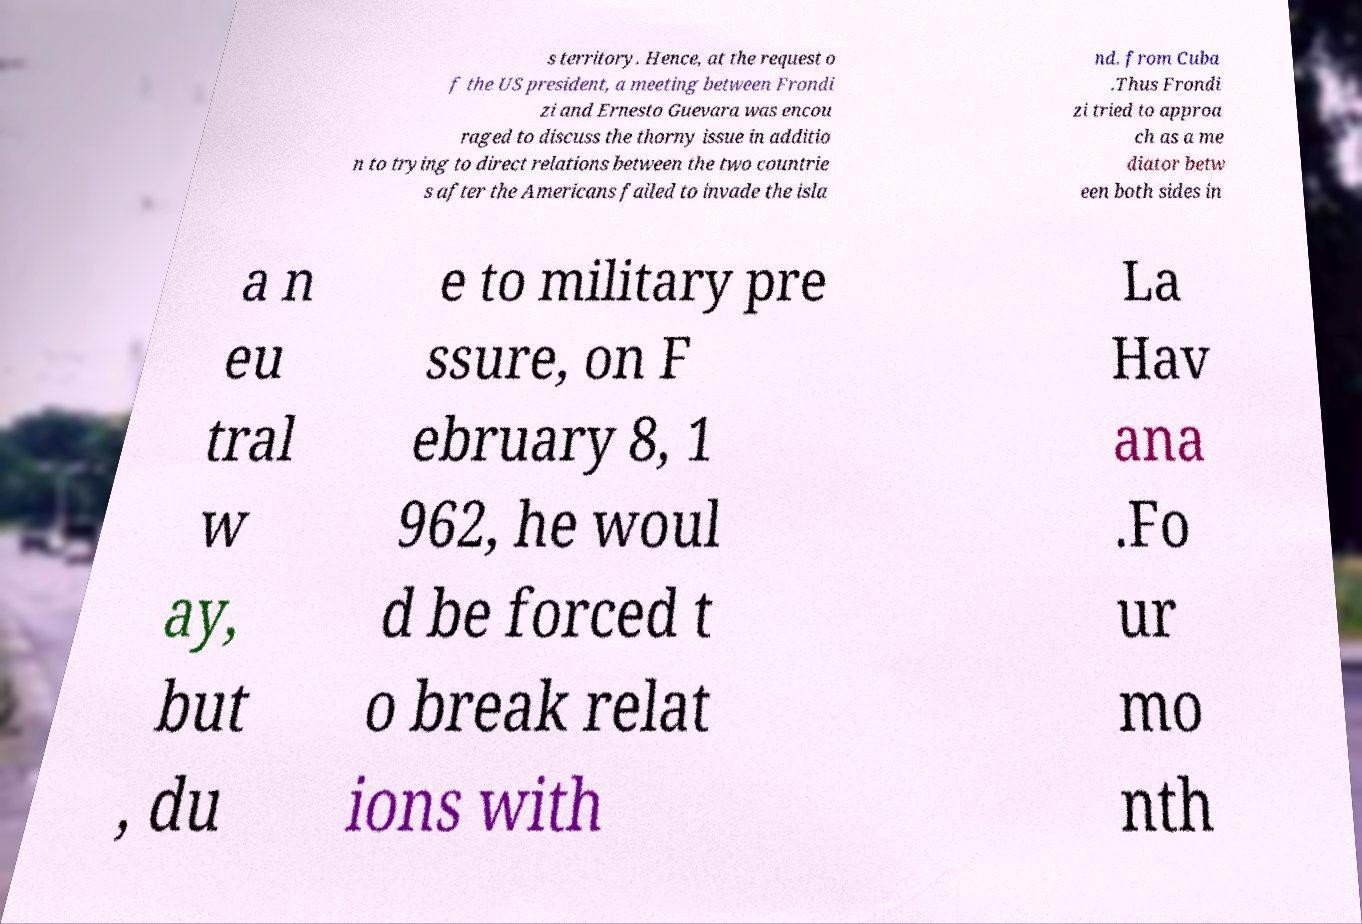Can you accurately transcribe the text from the provided image for me? s territory. Hence, at the request o f the US president, a meeting between Frondi zi and Ernesto Guevara was encou raged to discuss the thorny issue in additio n to trying to direct relations between the two countrie s after the Americans failed to invade the isla nd. from Cuba .Thus Frondi zi tried to approa ch as a me diator betw een both sides in a n eu tral w ay, but , du e to military pre ssure, on F ebruary 8, 1 962, he woul d be forced t o break relat ions with La Hav ana .Fo ur mo nth 